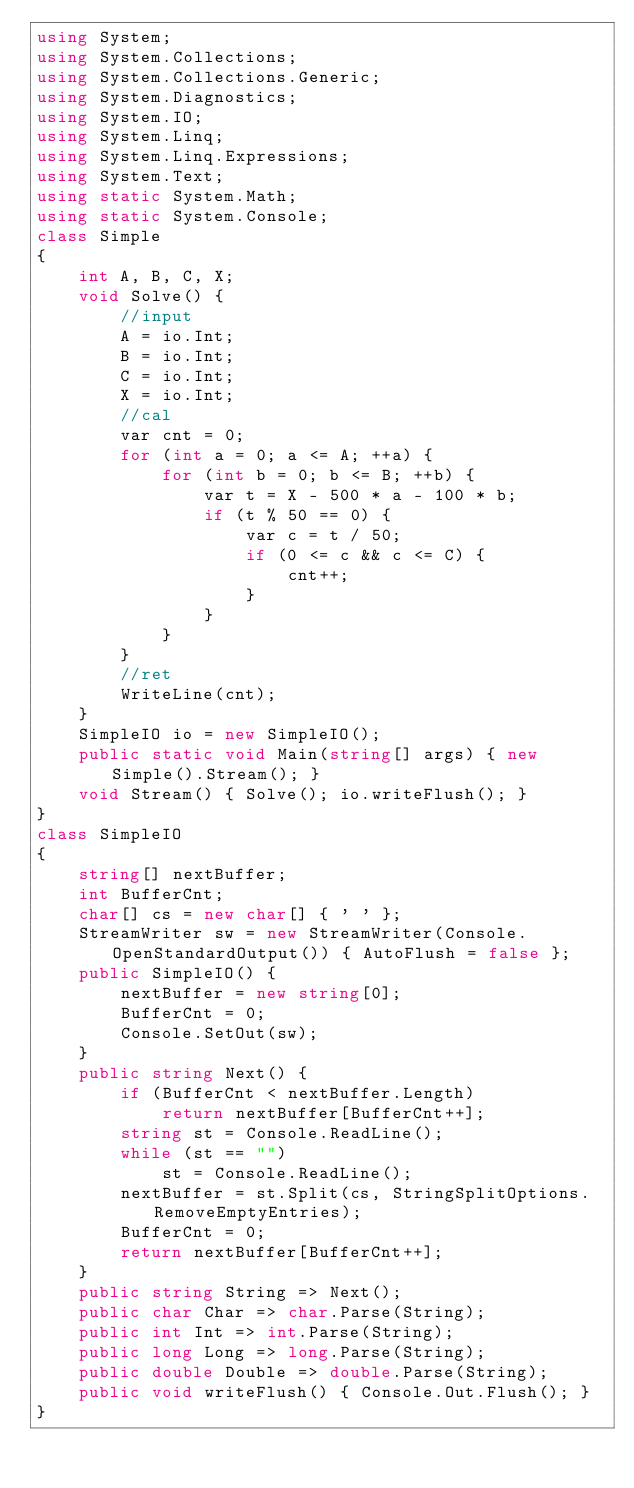<code> <loc_0><loc_0><loc_500><loc_500><_C#_>using System;
using System.Collections;
using System.Collections.Generic;
using System.Diagnostics;
using System.IO;
using System.Linq;
using System.Linq.Expressions;
using System.Text;
using static System.Math;
using static System.Console;
class Simple
{
    int A, B, C, X;
    void Solve() {
        //input
        A = io.Int;
        B = io.Int;
        C = io.Int;
        X = io.Int;
        //cal
        var cnt = 0;
        for (int a = 0; a <= A; ++a) {
            for (int b = 0; b <= B; ++b) {
                var t = X - 500 * a - 100 * b;
                if (t % 50 == 0) {
                    var c = t / 50;
                    if (0 <= c && c <= C) {
                        cnt++;
                    }
                }
            }
        }
        //ret
        WriteLine(cnt);
    }
    SimpleIO io = new SimpleIO();
    public static void Main(string[] args) { new Simple().Stream(); }
    void Stream() { Solve(); io.writeFlush(); }
}
class SimpleIO
{
    string[] nextBuffer;
    int BufferCnt;
    char[] cs = new char[] { ' ' };
    StreamWriter sw = new StreamWriter(Console.OpenStandardOutput()) { AutoFlush = false };
    public SimpleIO() {
        nextBuffer = new string[0];
        BufferCnt = 0;
        Console.SetOut(sw);
    }
    public string Next() {
        if (BufferCnt < nextBuffer.Length)
            return nextBuffer[BufferCnt++];
        string st = Console.ReadLine();
        while (st == "")
            st = Console.ReadLine();
        nextBuffer = st.Split(cs, StringSplitOptions.RemoveEmptyEntries);
        BufferCnt = 0;
        return nextBuffer[BufferCnt++];
    }
    public string String => Next();
    public char Char => char.Parse(String);
    public int Int => int.Parse(String);
    public long Long => long.Parse(String);
    public double Double => double.Parse(String);
    public void writeFlush() { Console.Out.Flush(); }
}
</code> 